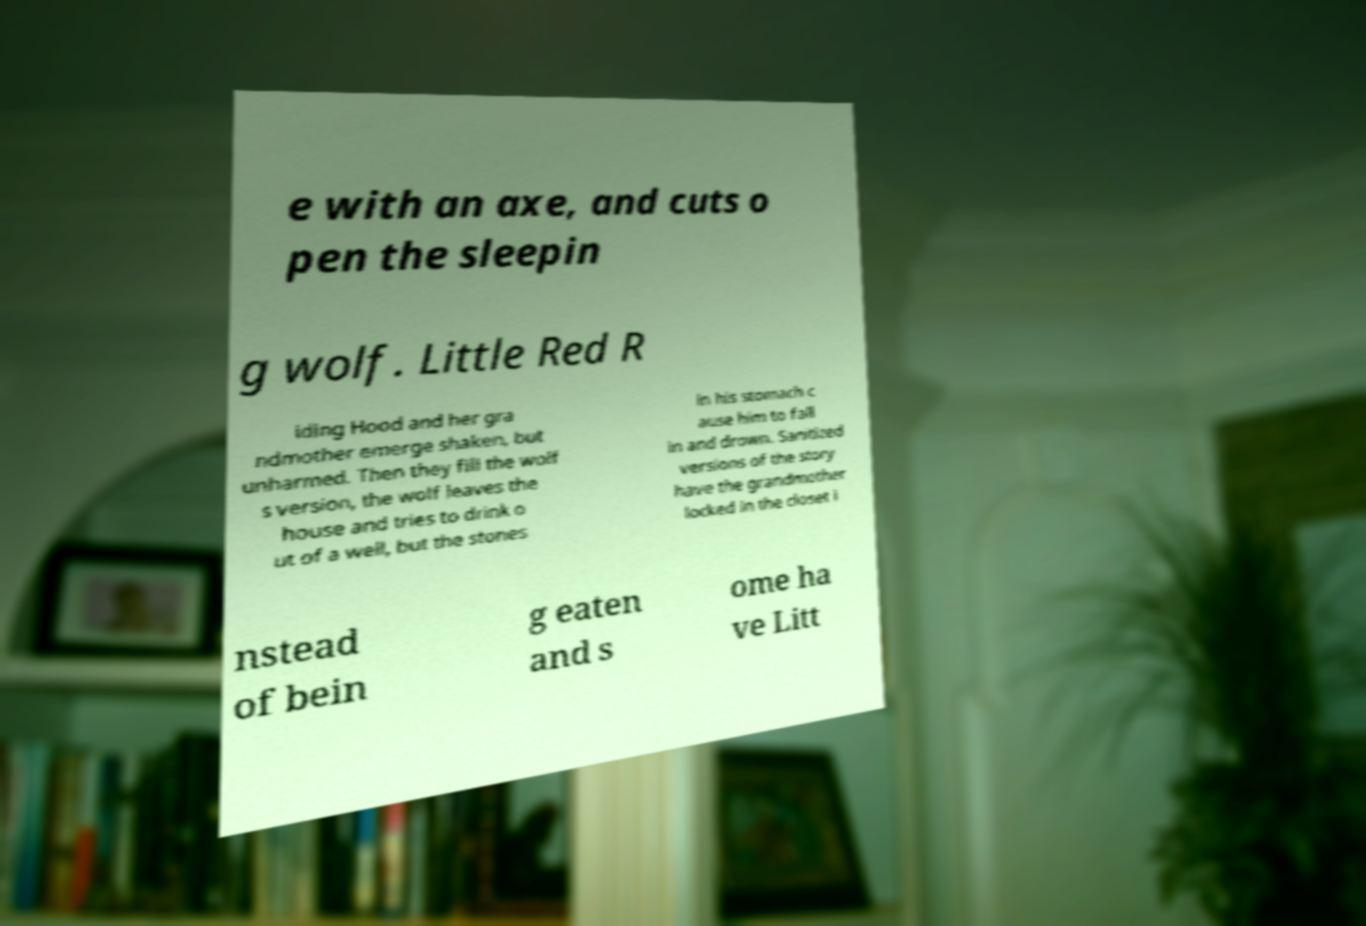There's text embedded in this image that I need extracted. Can you transcribe it verbatim? e with an axe, and cuts o pen the sleepin g wolf. Little Red R iding Hood and her gra ndmother emerge shaken, but unharmed. Then they fill the wolf s version, the wolf leaves the house and tries to drink o ut of a well, but the stones in his stomach c ause him to fall in and drown. Sanitized versions of the story have the grandmother locked in the closet i nstead of bein g eaten and s ome ha ve Litt 